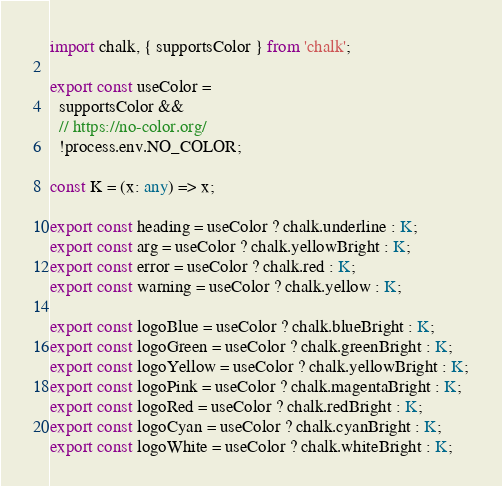<code> <loc_0><loc_0><loc_500><loc_500><_TypeScript_>import chalk, { supportsColor } from 'chalk';

export const useColor =
  supportsColor &&
  // https://no-color.org/
  !process.env.NO_COLOR;

const K = (x: any) => x;

export const heading = useColor ? chalk.underline : K;
export const arg = useColor ? chalk.yellowBright : K;
export const error = useColor ? chalk.red : K;
export const warning = useColor ? chalk.yellow : K;

export const logoBlue = useColor ? chalk.blueBright : K;
export const logoGreen = useColor ? chalk.greenBright : K;
export const logoYellow = useColor ? chalk.yellowBright : K;
export const logoPink = useColor ? chalk.magentaBright : K;
export const logoRed = useColor ? chalk.redBright : K;
export const logoCyan = useColor ? chalk.cyanBright : K;
export const logoWhite = useColor ? chalk.whiteBright : K;
</code> 